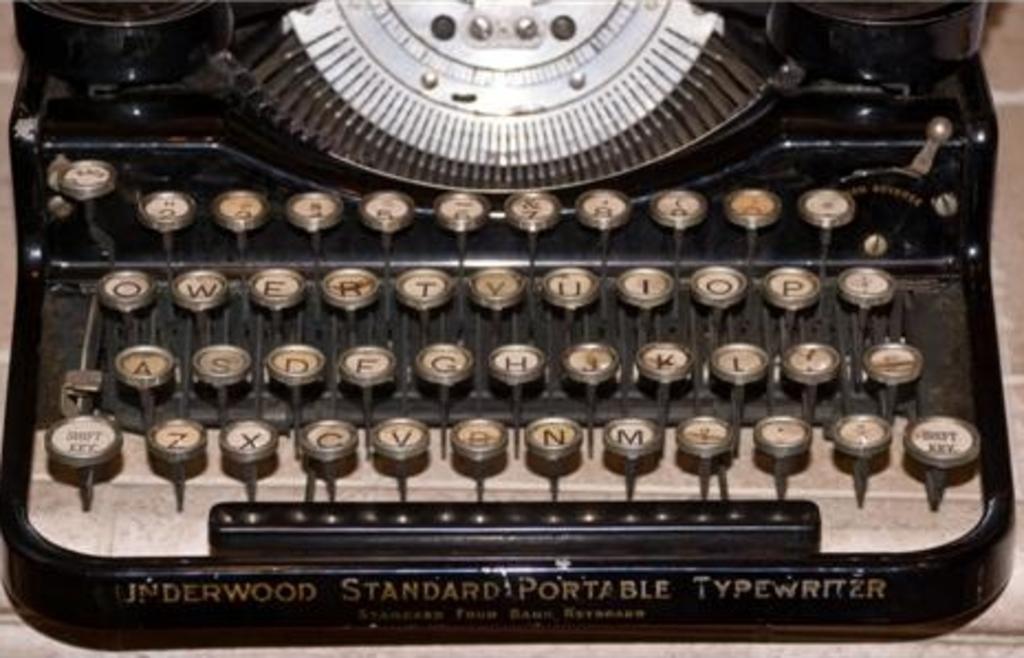What kind of machine is this?
Your answer should be compact. Typewriter. 